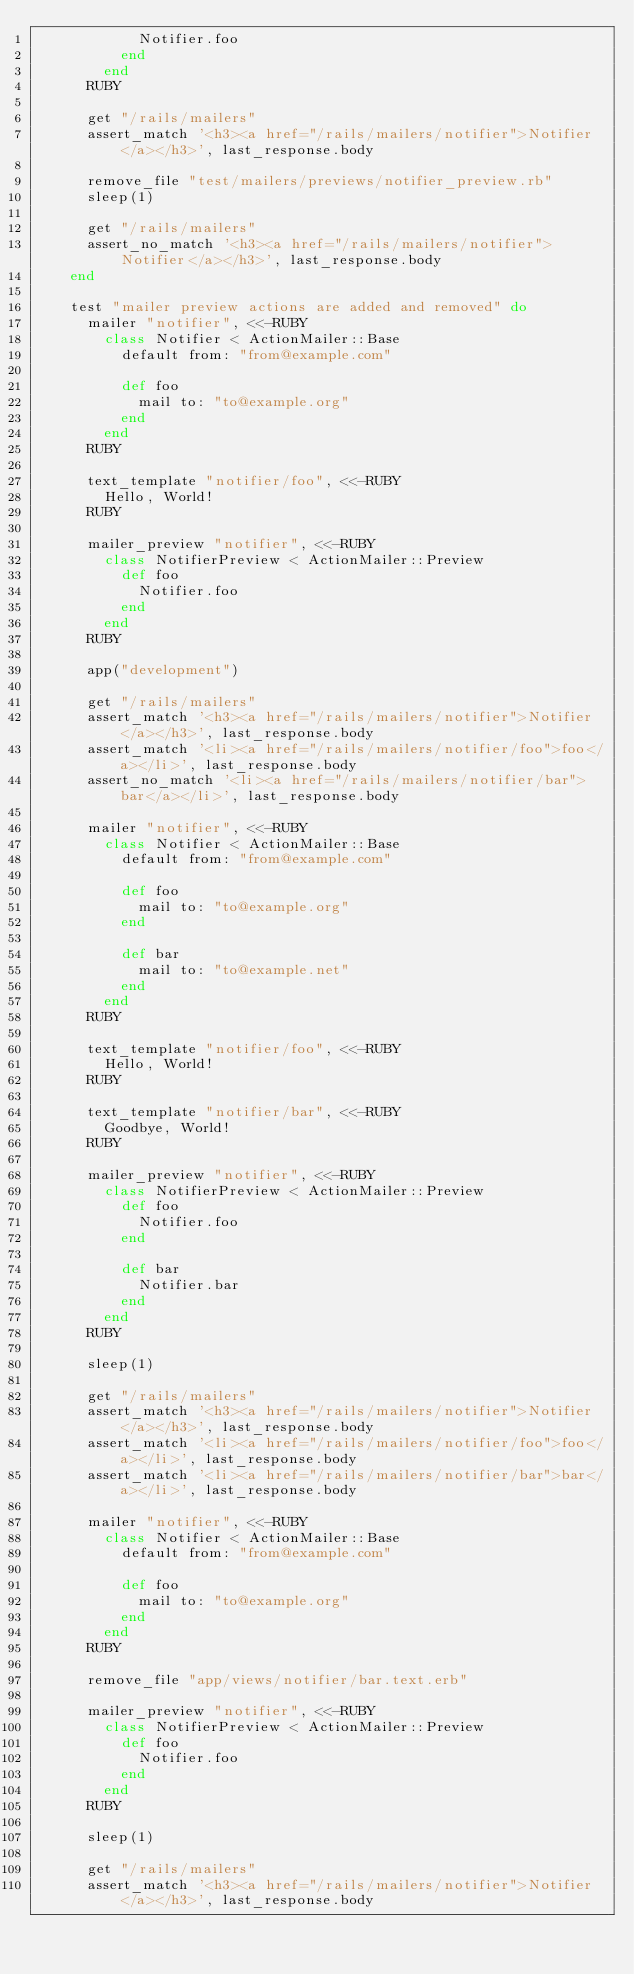Convert code to text. <code><loc_0><loc_0><loc_500><loc_500><_Ruby_>            Notifier.foo
          end
        end
      RUBY

      get "/rails/mailers"
      assert_match '<h3><a href="/rails/mailers/notifier">Notifier</a></h3>', last_response.body

      remove_file "test/mailers/previews/notifier_preview.rb"
      sleep(1)

      get "/rails/mailers"
      assert_no_match '<h3><a href="/rails/mailers/notifier">Notifier</a></h3>', last_response.body
    end

    test "mailer preview actions are added and removed" do
      mailer "notifier", <<-RUBY
        class Notifier < ActionMailer::Base
          default from: "from@example.com"

          def foo
            mail to: "to@example.org"
          end
        end
      RUBY

      text_template "notifier/foo", <<-RUBY
        Hello, World!
      RUBY

      mailer_preview "notifier", <<-RUBY
        class NotifierPreview < ActionMailer::Preview
          def foo
            Notifier.foo
          end
        end
      RUBY

      app("development")

      get "/rails/mailers"
      assert_match '<h3><a href="/rails/mailers/notifier">Notifier</a></h3>', last_response.body
      assert_match '<li><a href="/rails/mailers/notifier/foo">foo</a></li>', last_response.body
      assert_no_match '<li><a href="/rails/mailers/notifier/bar">bar</a></li>', last_response.body

      mailer "notifier", <<-RUBY
        class Notifier < ActionMailer::Base
          default from: "from@example.com"

          def foo
            mail to: "to@example.org"
          end

          def bar
            mail to: "to@example.net"
          end
        end
      RUBY

      text_template "notifier/foo", <<-RUBY
        Hello, World!
      RUBY

      text_template "notifier/bar", <<-RUBY
        Goodbye, World!
      RUBY

      mailer_preview "notifier", <<-RUBY
        class NotifierPreview < ActionMailer::Preview
          def foo
            Notifier.foo
          end

          def bar
            Notifier.bar
          end
        end
      RUBY

      sleep(1)

      get "/rails/mailers"
      assert_match '<h3><a href="/rails/mailers/notifier">Notifier</a></h3>', last_response.body
      assert_match '<li><a href="/rails/mailers/notifier/foo">foo</a></li>', last_response.body
      assert_match '<li><a href="/rails/mailers/notifier/bar">bar</a></li>', last_response.body

      mailer "notifier", <<-RUBY
        class Notifier < ActionMailer::Base
          default from: "from@example.com"

          def foo
            mail to: "to@example.org"
          end
        end
      RUBY

      remove_file "app/views/notifier/bar.text.erb"

      mailer_preview "notifier", <<-RUBY
        class NotifierPreview < ActionMailer::Preview
          def foo
            Notifier.foo
          end
        end
      RUBY

      sleep(1)

      get "/rails/mailers"
      assert_match '<h3><a href="/rails/mailers/notifier">Notifier</a></h3>', last_response.body</code> 